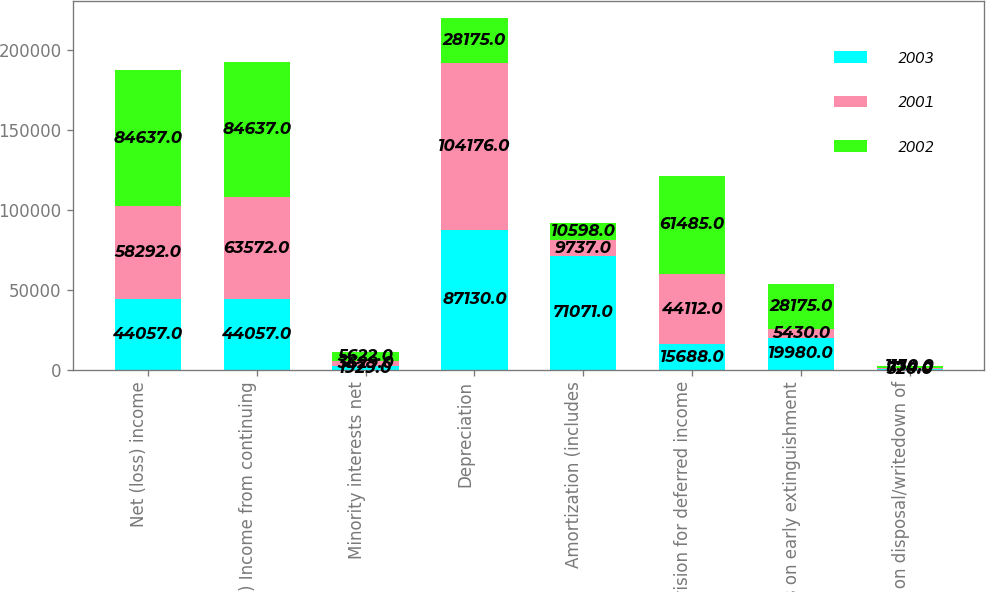Convert chart to OTSL. <chart><loc_0><loc_0><loc_500><loc_500><stacked_bar_chart><ecel><fcel>Net (loss) income<fcel>(Loss) Income from continuing<fcel>Minority interests net<fcel>Depreciation<fcel>Amortization (includes<fcel>Provision for deferred income<fcel>Loss on early extinguishment<fcel>Loss on disposal/writedown of<nl><fcel>2003<fcel>44057<fcel>44057<fcel>1929<fcel>87130<fcel>71071<fcel>15688<fcel>19980<fcel>320<nl><fcel>2001<fcel>58292<fcel>63572<fcel>3629<fcel>104176<fcel>9737<fcel>44112<fcel>5430<fcel>774<nl><fcel>2002<fcel>84637<fcel>84637<fcel>5622<fcel>28175<fcel>10598<fcel>61485<fcel>28175<fcel>1130<nl></chart> 